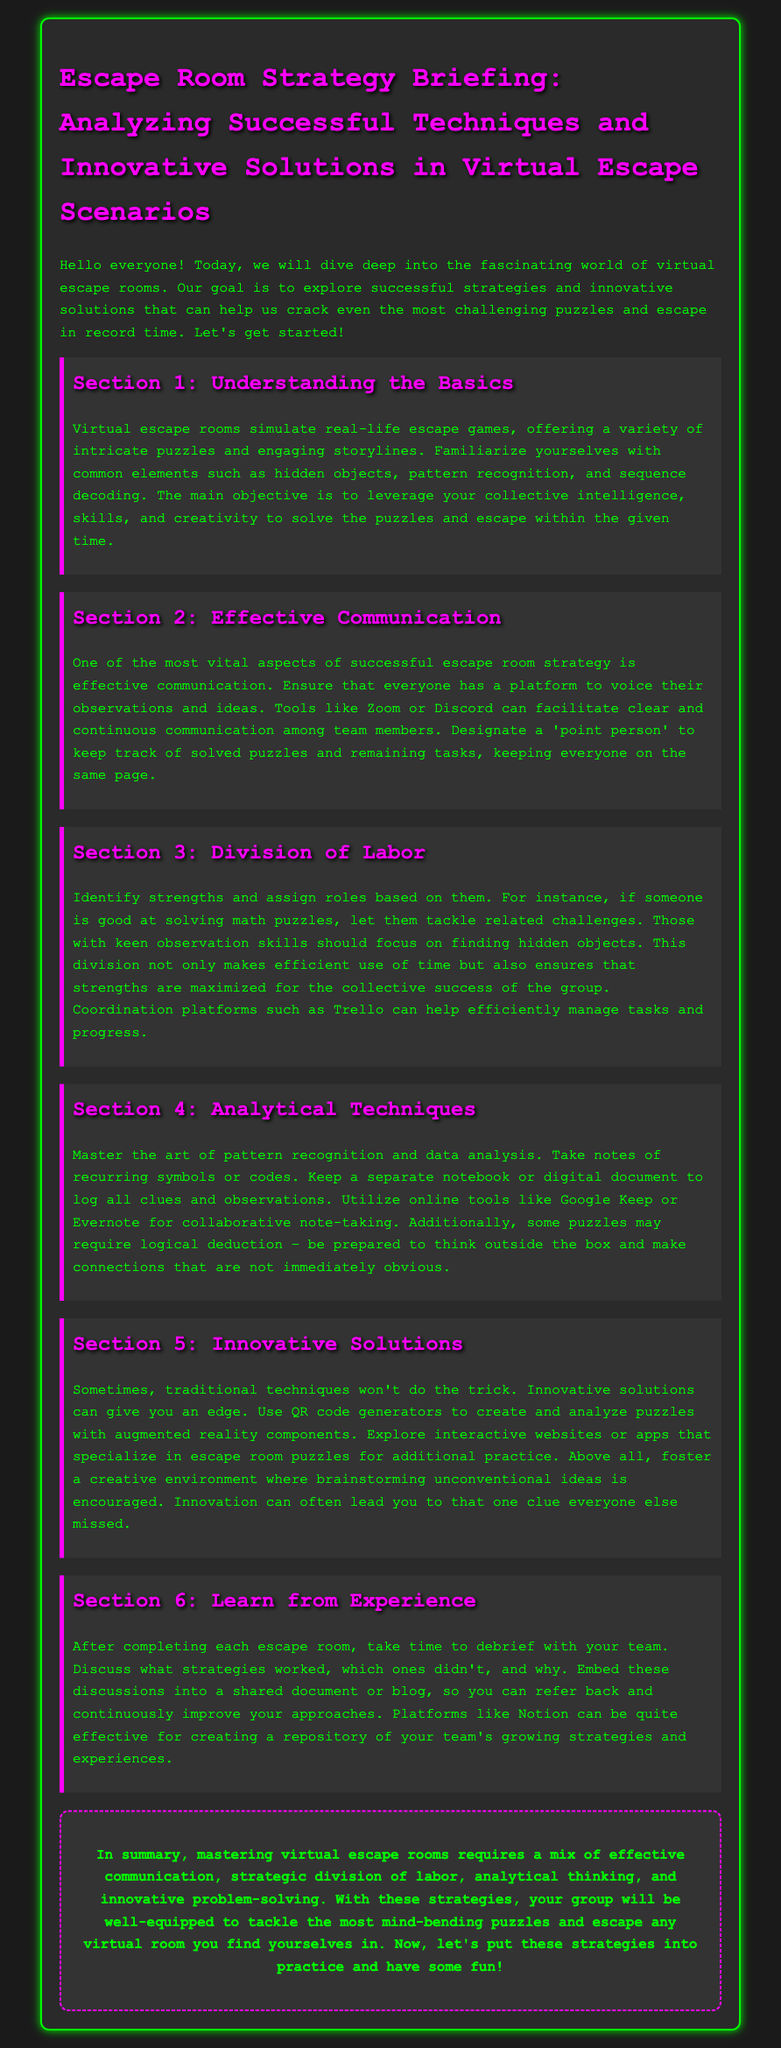What is the main objective of virtual escape rooms? The main objective is to leverage your collective intelligence, skills, and creativity to solve the puzzles and escape within the given time.
Answer: Leverage your collective intelligence, skills, and creativity What should be designated to keep track of solved puzzles? The document suggests designating a 'point person' to keep track of solved puzzles and remaining tasks.
Answer: Point person What online tools are mentioned for collaborative note-taking? The section mentions online tools like Google Keep or Evernote for collaborative note-taking.
Answer: Google Keep, Evernote What is essential to ensure effective communication in escape rooms? The document emphasizes the need for a platform to voice observations and ideas among team members.
Answer: A platform to voice observations What should you do after completing each escape room? After completing each escape room, it is important to take time to debrief with your team.
Answer: Debrief with your team Which platform can help create a repository of strategies? Notion is emphasized as effective for creating a repository of the team's growing strategies and experiences.
Answer: Notion What is suggested for those good at solving math puzzles? The suggestion is to let those good at solving math puzzles tackle related challenges.
Answer: Tackle related challenges What technique involves analyzing recurring symbols or codes? Mastering the art of pattern recognition involves analyzing recurring symbols or codes.
Answer: Pattern recognition What kind of environment should be fostered for innovative solutions? A creative environment where brainstorming unconventional ideas is encouraged should be fostered.
Answer: Creative environment 